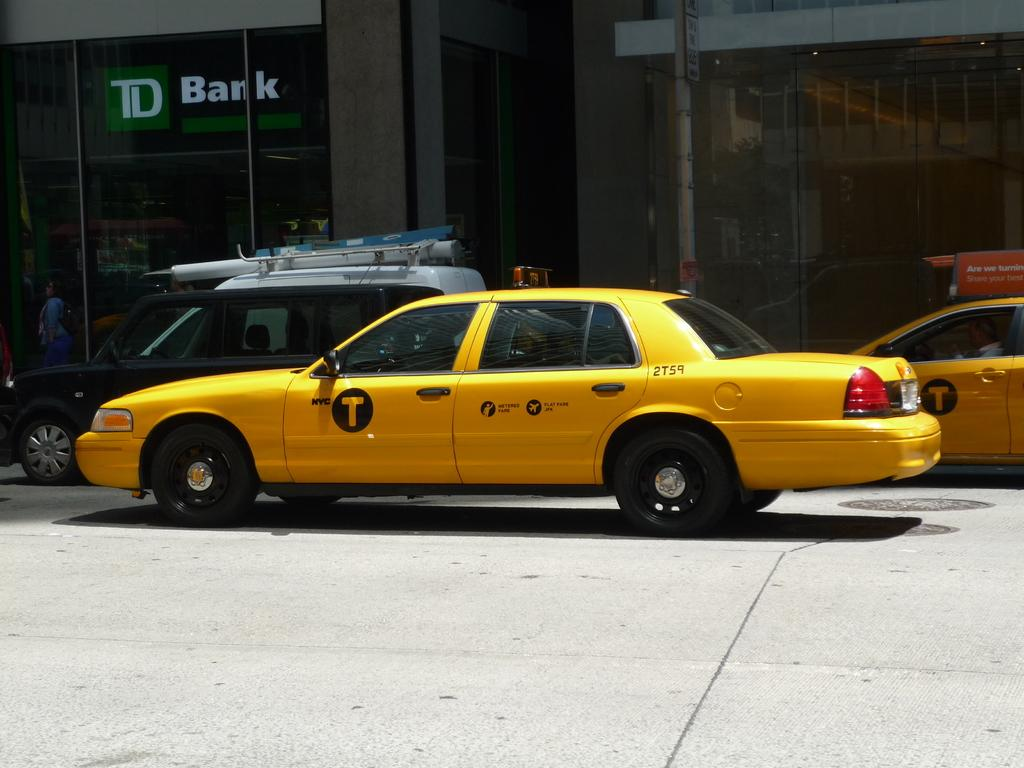<image>
Present a compact description of the photo's key features. A taxi is under a sign that has the word Bark on it. 